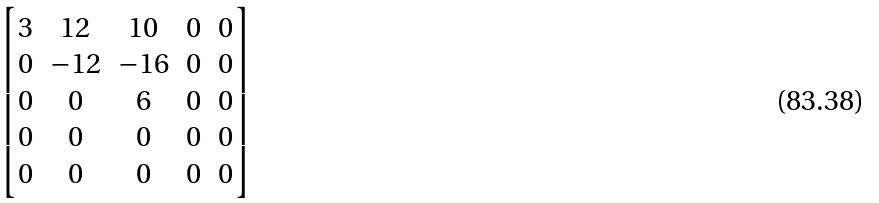Convert formula to latex. <formula><loc_0><loc_0><loc_500><loc_500>\begin{bmatrix} 3 & 1 2 & 1 0 & 0 & 0 \\ 0 & - 1 2 & - 1 6 & 0 & 0 \\ 0 & 0 & 6 & 0 & 0 \\ 0 & 0 & 0 & 0 & 0 \\ 0 & 0 & 0 & 0 & 0 \end{bmatrix}</formula> 